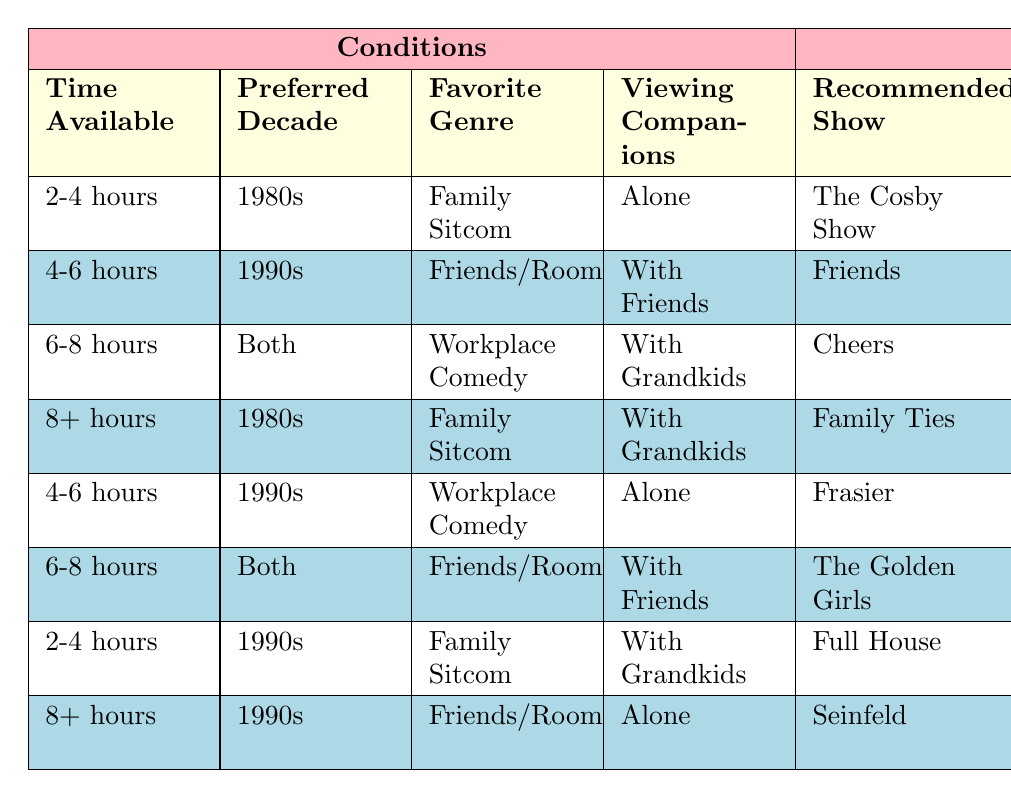What is the recommended show for someone with 4-6 hours of time, who prefers sitcoms from the 1990s and wants to watch with friends? In the table, I look at the row where "4-6 hours" is listed as Time Available, "1990s" is the Preferred Decade, and "Friends/Roommates" is the Favorite Genre. I find that the recommended show under these conditions is "Friends."
Answer: Friends What snack is suggested for a viewing session of "Cheers" with grandkids for 6-8 hours? The show "Cheers" is listed under the conditions of "6-8 hours" of time available, "Both" decades, "Workplace Comedy" genre, and "With Grandkids." The corresponding snack suggestion is "Ice Cream Sundae Bar."
Answer: Ice Cream Sundae Bar Is "The Golden Girls" recommended for a viewing party that lasts 6-8 hours with friends? I check the conditions for "6-8 hours" and "With Friends" but the genre in this case is "Friends/Roommates" with "The Golden Girls" as the recommended show. Hence, it does fit the criteria. Yes, it is recommended for those conditions.
Answer: Yes Which show should someone watch if they have 8+ hours, prefer 1980s family sitcoms, and want to watch with grandkids? I look at the row for "8+ hours," "1980s," "Family Sitcom," and "With Grandkids." The show is "Family Ties."
Answer: Family Ties How many episodes are recommended for watching "Frasier" alone for 4-6 hours? In the row where "Frasier" is recommended, I find that for "4-6 hours" of viewing time, the number of episodes suggested is "7-9."
Answer: 7-9 